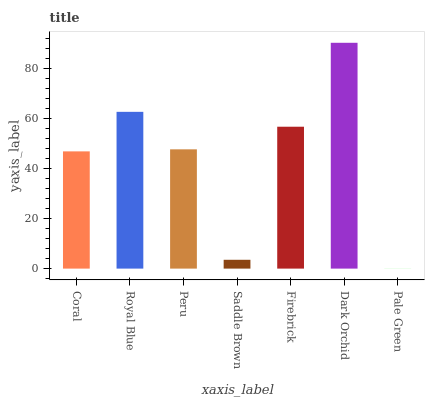Is Pale Green the minimum?
Answer yes or no. Yes. Is Dark Orchid the maximum?
Answer yes or no. Yes. Is Royal Blue the minimum?
Answer yes or no. No. Is Royal Blue the maximum?
Answer yes or no. No. Is Royal Blue greater than Coral?
Answer yes or no. Yes. Is Coral less than Royal Blue?
Answer yes or no. Yes. Is Coral greater than Royal Blue?
Answer yes or no. No. Is Royal Blue less than Coral?
Answer yes or no. No. Is Peru the high median?
Answer yes or no. Yes. Is Peru the low median?
Answer yes or no. Yes. Is Firebrick the high median?
Answer yes or no. No. Is Dark Orchid the low median?
Answer yes or no. No. 